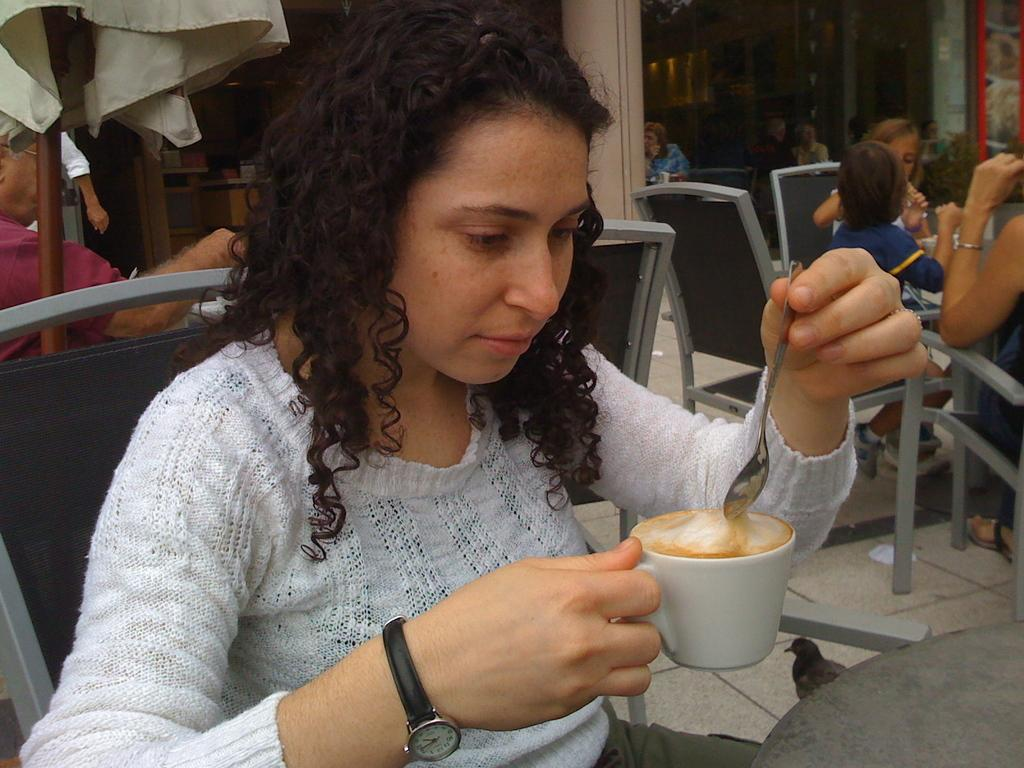What is the main subject of the image? There is a lady person in the image. Can you describe the lady person's attire? The lady person is wearing a white dress. What is the lady person holding in the image? The lady person is holding a cup of coffee. What can be seen in the background of the image? There is a group of persons in the background of the image. What are the group of persons doing in the image? The group of persons are sitting at a table. What type of poison is the lady person using to flavor her coffee in the image? There is no mention of poison or any flavoring in the image; the lady person is simply holding a cup of coffee. Is the lady person's brother present in the image? There is no mention of a brother or any family members in the image; the focus is on the lady person and the group of persons in the background. 